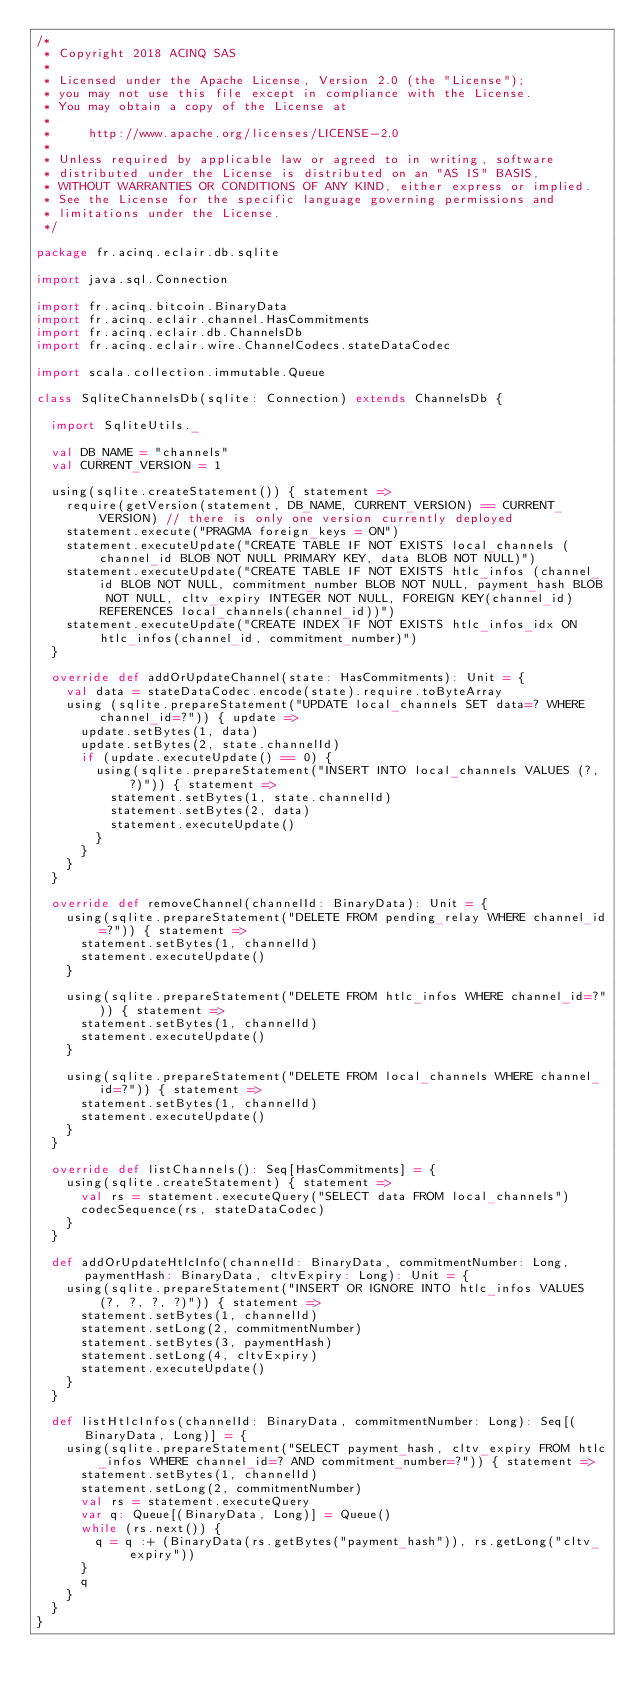Convert code to text. <code><loc_0><loc_0><loc_500><loc_500><_Scala_>/*
 * Copyright 2018 ACINQ SAS
 *
 * Licensed under the Apache License, Version 2.0 (the "License");
 * you may not use this file except in compliance with the License.
 * You may obtain a copy of the License at
 *
 *     http://www.apache.org/licenses/LICENSE-2.0
 *
 * Unless required by applicable law or agreed to in writing, software
 * distributed under the License is distributed on an "AS IS" BASIS,
 * WITHOUT WARRANTIES OR CONDITIONS OF ANY KIND, either express or implied.
 * See the License for the specific language governing permissions and
 * limitations under the License.
 */

package fr.acinq.eclair.db.sqlite

import java.sql.Connection

import fr.acinq.bitcoin.BinaryData
import fr.acinq.eclair.channel.HasCommitments
import fr.acinq.eclair.db.ChannelsDb
import fr.acinq.eclair.wire.ChannelCodecs.stateDataCodec

import scala.collection.immutable.Queue

class SqliteChannelsDb(sqlite: Connection) extends ChannelsDb {

  import SqliteUtils._

  val DB_NAME = "channels"
  val CURRENT_VERSION = 1

  using(sqlite.createStatement()) { statement =>
    require(getVersion(statement, DB_NAME, CURRENT_VERSION) == CURRENT_VERSION) // there is only one version currently deployed
    statement.execute("PRAGMA foreign_keys = ON")
    statement.executeUpdate("CREATE TABLE IF NOT EXISTS local_channels (channel_id BLOB NOT NULL PRIMARY KEY, data BLOB NOT NULL)")
    statement.executeUpdate("CREATE TABLE IF NOT EXISTS htlc_infos (channel_id BLOB NOT NULL, commitment_number BLOB NOT NULL, payment_hash BLOB NOT NULL, cltv_expiry INTEGER NOT NULL, FOREIGN KEY(channel_id) REFERENCES local_channels(channel_id))")
    statement.executeUpdate("CREATE INDEX IF NOT EXISTS htlc_infos_idx ON htlc_infos(channel_id, commitment_number)")
  }

  override def addOrUpdateChannel(state: HasCommitments): Unit = {
    val data = stateDataCodec.encode(state).require.toByteArray
    using (sqlite.prepareStatement("UPDATE local_channels SET data=? WHERE channel_id=?")) { update =>
      update.setBytes(1, data)
      update.setBytes(2, state.channelId)
      if (update.executeUpdate() == 0) {
        using(sqlite.prepareStatement("INSERT INTO local_channels VALUES (?, ?)")) { statement =>
          statement.setBytes(1, state.channelId)
          statement.setBytes(2, data)
          statement.executeUpdate()
        }
      }
    }
  }

  override def removeChannel(channelId: BinaryData): Unit = {
    using(sqlite.prepareStatement("DELETE FROM pending_relay WHERE channel_id=?")) { statement =>
      statement.setBytes(1, channelId)
      statement.executeUpdate()
    }

    using(sqlite.prepareStatement("DELETE FROM htlc_infos WHERE channel_id=?")) { statement =>
      statement.setBytes(1, channelId)
      statement.executeUpdate()
    }

    using(sqlite.prepareStatement("DELETE FROM local_channels WHERE channel_id=?")) { statement =>
      statement.setBytes(1, channelId)
      statement.executeUpdate()
    }
  }

  override def listChannels(): Seq[HasCommitments] = {
    using(sqlite.createStatement) { statement =>
      val rs = statement.executeQuery("SELECT data FROM local_channels")
      codecSequence(rs, stateDataCodec)
    }
  }

  def addOrUpdateHtlcInfo(channelId: BinaryData, commitmentNumber: Long, paymentHash: BinaryData, cltvExpiry: Long): Unit = {
    using(sqlite.prepareStatement("INSERT OR IGNORE INTO htlc_infos VALUES (?, ?, ?, ?)")) { statement =>
      statement.setBytes(1, channelId)
      statement.setLong(2, commitmentNumber)
      statement.setBytes(3, paymentHash)
      statement.setLong(4, cltvExpiry)
      statement.executeUpdate()
    }
  }

  def listHtlcInfos(channelId: BinaryData, commitmentNumber: Long): Seq[(BinaryData, Long)] = {
    using(sqlite.prepareStatement("SELECT payment_hash, cltv_expiry FROM htlc_infos WHERE channel_id=? AND commitment_number=?")) { statement =>
      statement.setBytes(1, channelId)
      statement.setLong(2, commitmentNumber)
      val rs = statement.executeQuery
      var q: Queue[(BinaryData, Long)] = Queue()
      while (rs.next()) {
        q = q :+ (BinaryData(rs.getBytes("payment_hash")), rs.getLong("cltv_expiry"))
      }
      q
    }
  }
}
</code> 